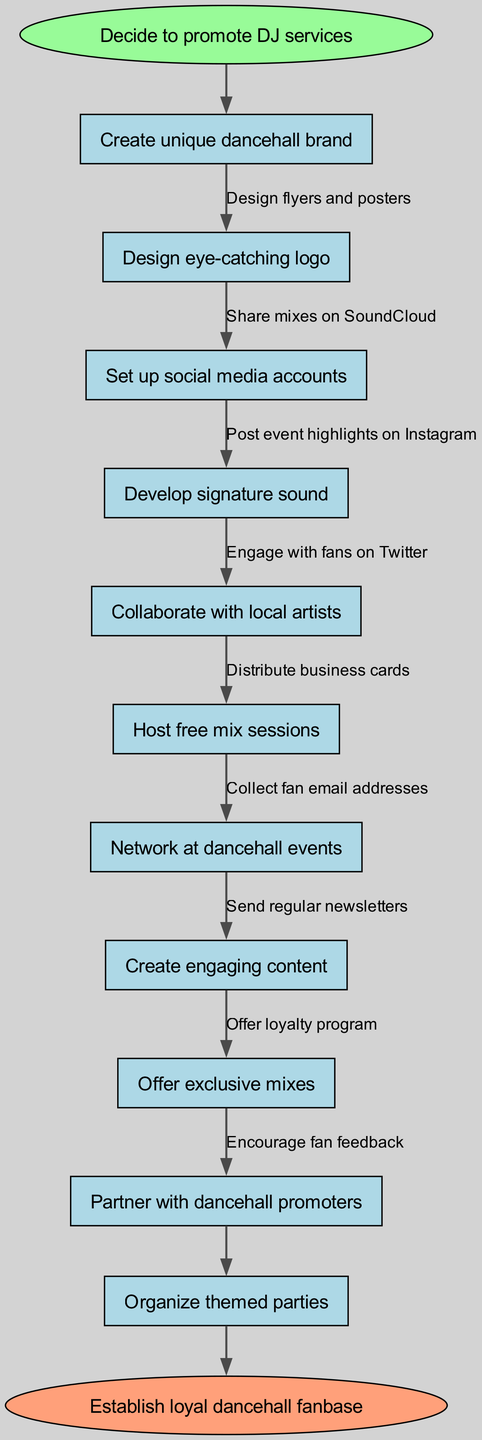What is the first action in the flow chart? The first action is indicated as directly following the start node, which is "Create unique dancehall brand". The flow chart starts with this node immediately after the starting point.
Answer: Create unique dancehall brand How many main nodes are in the diagram? The diagram lists a total of 10 main nodes representing various activities related to promoting DJ services, as counted in the nodes section.
Answer: 10 What is the last action before establishing the loyal fanbase? The last action node before reaching the end node is "Organize themed parties". This node connects directly to the end node according to the flow of the diagram.
Answer: Organize themed parties What type of social media engagement is suggested after creating social media accounts? After setting up social media accounts, the diagram suggests "Engage with fans on Twitter". This action follows the establishment of social media accounts in the sequence of nodes.
Answer: Engage with fans on Twitter Which activity involves collaborating with others? The activity "Collaborate with local artists" shows a collaborative approach in the promotional strategy, as indicated by its position in the flow structure.
Answer: Collaborate with local artists How many edges connect the nodes in the flow chart? There are a total of 9 edges connecting the main nodes based on the diagram's structure. Each edge represents a relationship or action leading from one node to another.
Answer: 9 What is an example of content to be created for engagement? The flow chart includes "Create engaging content" as a specific action for maintaining engagement with fans, representing the kind of content to focus on.
Answer: Create engaging content Which marketing approach involves a reward system for fans? The approach labeled "Offer loyalty program" introduces a reward system aimed at retaining fans, as highlighted in the flow structure.
Answer: Offer loyalty program 